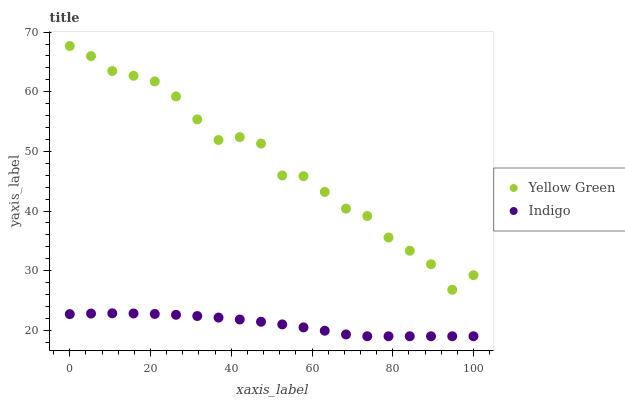Does Indigo have the minimum area under the curve?
Answer yes or no. Yes. Does Yellow Green have the maximum area under the curve?
Answer yes or no. Yes. Does Yellow Green have the minimum area under the curve?
Answer yes or no. No. Is Indigo the smoothest?
Answer yes or no. Yes. Is Yellow Green the roughest?
Answer yes or no. Yes. Is Yellow Green the smoothest?
Answer yes or no. No. Does Indigo have the lowest value?
Answer yes or no. Yes. Does Yellow Green have the lowest value?
Answer yes or no. No. Does Yellow Green have the highest value?
Answer yes or no. Yes. Is Indigo less than Yellow Green?
Answer yes or no. Yes. Is Yellow Green greater than Indigo?
Answer yes or no. Yes. Does Indigo intersect Yellow Green?
Answer yes or no. No. 